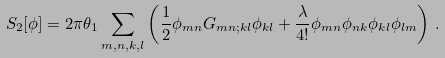<formula> <loc_0><loc_0><loc_500><loc_500>S _ { 2 } [ \phi ] & = 2 \pi \theta _ { 1 } \sum _ { m , n , k , l } \left ( \frac { 1 } { 2 } \phi _ { m n } G _ { m n ; k l } \phi _ { k l } + \frac { \lambda } { 4 ! } \phi _ { m n } \phi _ { n k } \phi _ { k l } \phi _ { l m } \right ) \, .</formula> 